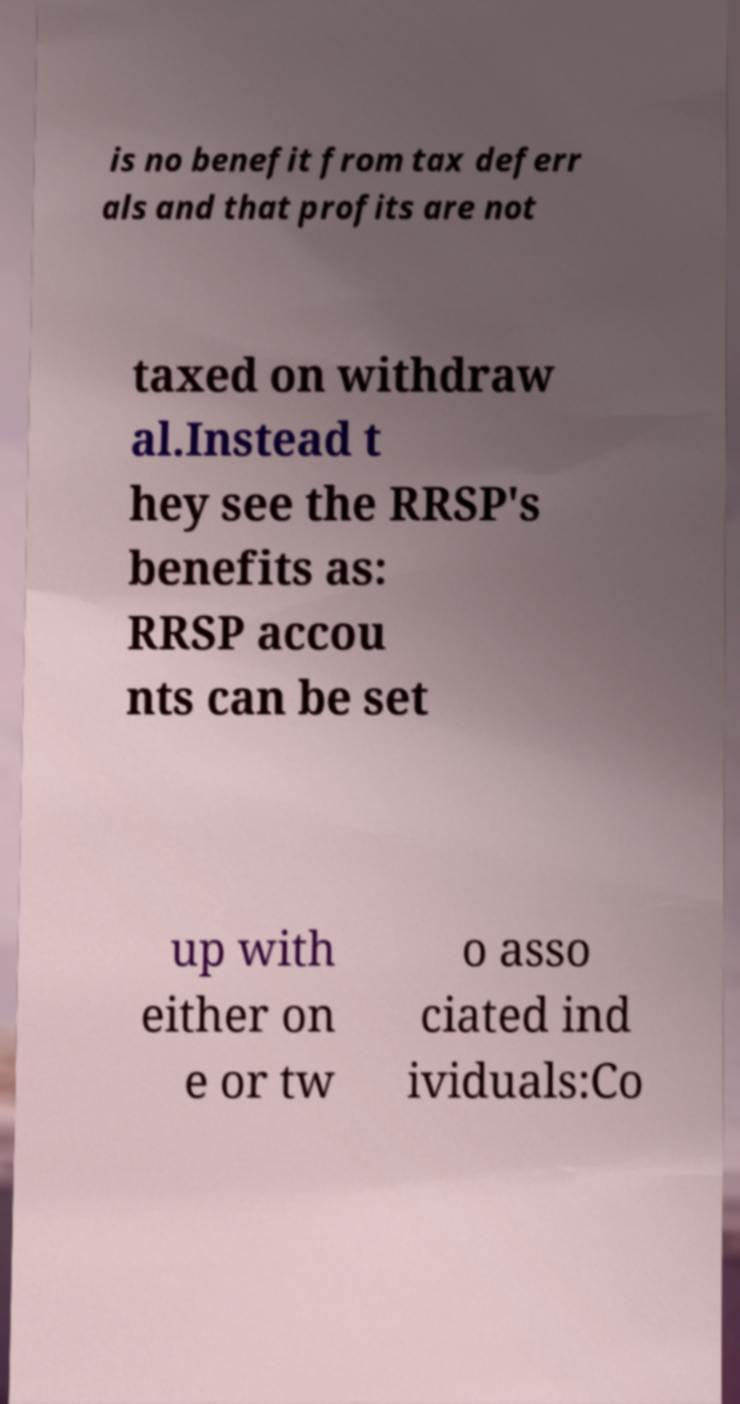Please read and relay the text visible in this image. What does it say? is no benefit from tax deferr als and that profits are not taxed on withdraw al.Instead t hey see the RRSP's benefits as: RRSP accou nts can be set up with either on e or tw o asso ciated ind ividuals:Co 